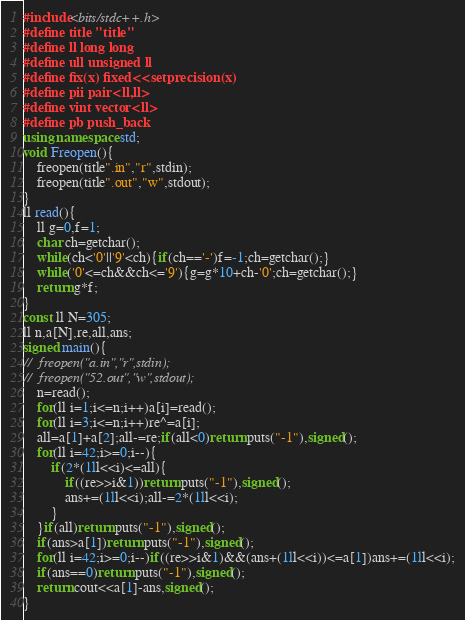<code> <loc_0><loc_0><loc_500><loc_500><_C++_>#include<bits/stdc++.h>
#define title "title"
#define ll long long
#define ull unsigned ll
#define fix(x) fixed<<setprecision(x)
#define pii pair<ll,ll>
#define vint vector<ll>
#define pb push_back
using namespace std;
void Freopen(){
	freopen(title".in","r",stdin);
	freopen(title".out","w",stdout);
}
ll read(){
	ll g=0,f=1;
	char ch=getchar();
	while(ch<'0'||'9'<ch){if(ch=='-')f=-1;ch=getchar();}
	while('0'<=ch&&ch<='9'){g=g*10+ch-'0';ch=getchar();}
	return g*f;
}
const ll N=305;
ll n,a[N],re,all,ans;
signed main(){
//	freopen("a.in","r",stdin);
//	freopen("52.out","w",stdout);
	n=read();
	for(ll i=1;i<=n;i++)a[i]=read();
	for(ll i=3;i<=n;i++)re^=a[i];
	all=a[1]+a[2];all-=re;if(all<0)return puts("-1"),signed();
	for(ll i=42;i>=0;i--){
		if(2*(1ll<<i)<=all){
			if((re>>i&1))return puts("-1"),signed();
			ans+=(1ll<<i);all-=2*(1ll<<i);
		}
	}if(all)return puts("-1"),signed();
	if(ans>a[1])return puts("-1"),signed();
	for(ll i=42;i>=0;i--)if((re>>i&1)&&(ans+(1ll<<i))<=a[1])ans+=(1ll<<i);
	if(ans==0)return puts("-1"),signed();
	return cout<<a[1]-ans,signed();
}</code> 